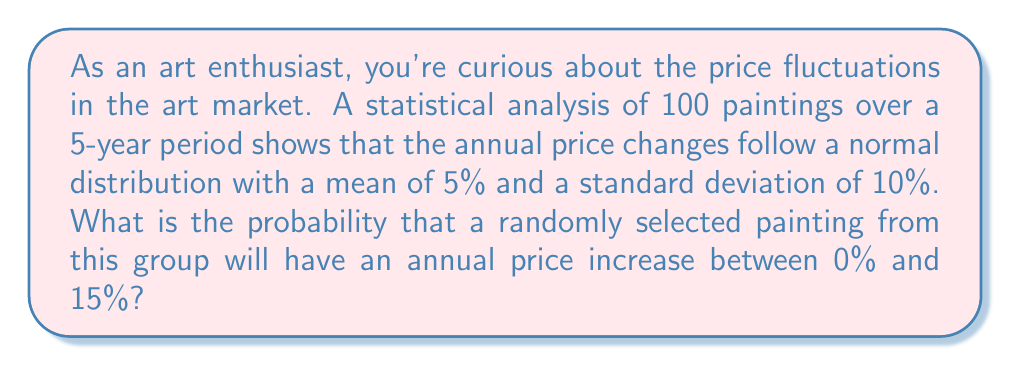Help me with this question. Let's approach this step-by-step:

1) We're dealing with a normal distribution where:
   Mean (μ) = 5%
   Standard deviation (σ) = 10%

2) We want to find the probability of a price increase between 0% and 15%.

3) To use the standard normal distribution table, we need to convert these values to z-scores:

   For 0%: $z_1 = \frac{0 - 5}{10} = -0.5$
   For 15%: $z_2 = \frac{15 - 5}{10} = 1$

4) Now, we need to find P(-0.5 < Z < 1)

5) This can be rewritten as: P(Z < 1) - P(Z < -0.5)

6) Using a standard normal distribution table or calculator:
   P(Z < 1) ≈ 0.8413
   P(Z < -0.5) ≈ 0.3085

7) Therefore, P(-0.5 < Z < 1) = 0.8413 - 0.3085 = 0.5328

8) Convert to percentage: 0.5328 * 100 = 53.28%
Answer: 53.28% 